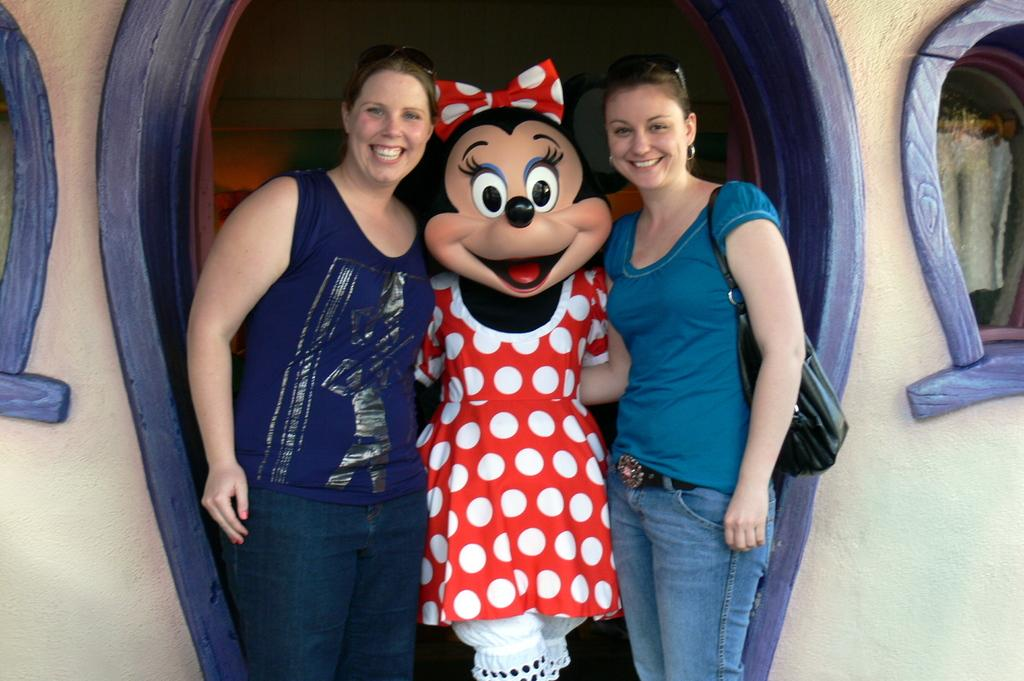How many women are in the image? There are two women standing and smiling in the image. What is the person between the two women wearing? The person between the two women is wearing a costume. What can be seen behind the women in the image? There is a wall visible in the image. Are there any openings in the wall visible in the image? Yes, there are windows in the image. What type of base is the committee offering in the image? There is no mention of a committee or base in the image; it features two women and a person in a costume. 